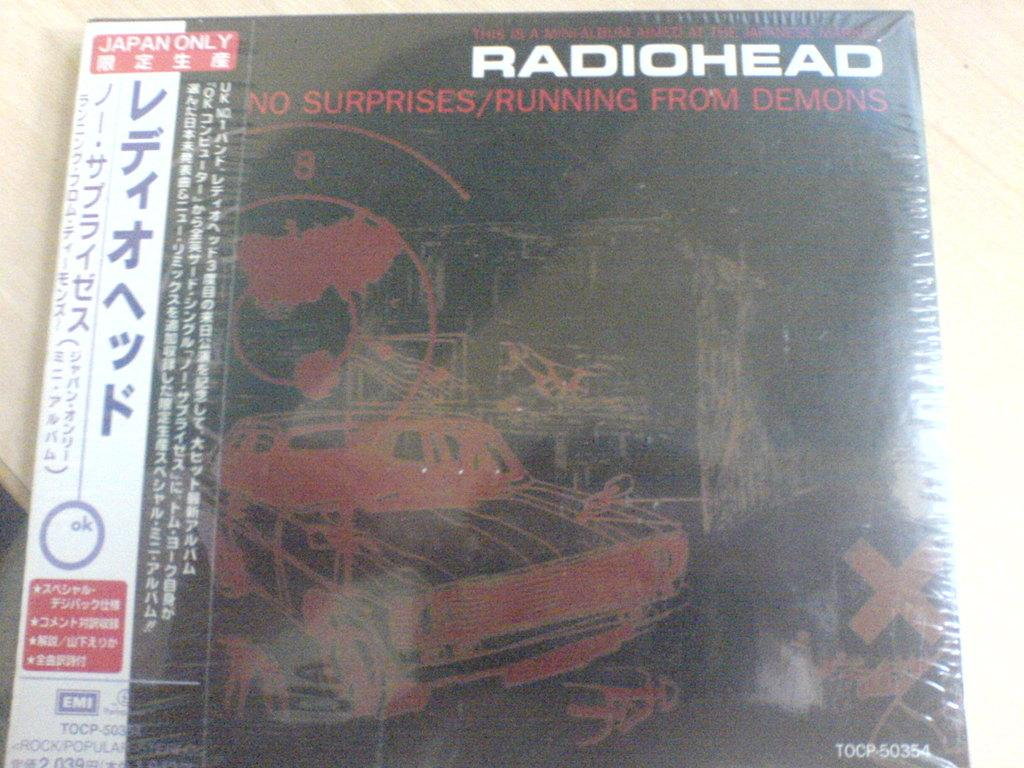Provide a one-sentence caption for the provided image. A Radiohead album called No Surprises/Running from Demons for Japan only. 